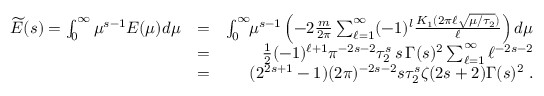<formula> <loc_0><loc_0><loc_500><loc_500>\begin{array} { r l r } { \widetilde { E } ( s ) = \int _ { 0 } ^ { \infty } \mu ^ { s - 1 } E ( \mu ) d \mu } & { = } & { \int _ { 0 } ^ { \infty } \, \mu ^ { s - 1 } \left ( - 2 { \frac { m } { 2 \pi } } \sum _ { \ell = 1 } ^ { \infty } ( - 1 ) ^ { l } { \frac { K _ { 1 } ( 2 \pi \ell \sqrt { \mu / \tau _ { 2 } } ) } { \ell } } \right ) d \mu } \\ & { = } & { { \frac { 1 } { 2 } } ( - 1 ) ^ { \ell + 1 } \pi ^ { - 2 s - 2 } \tau _ { 2 } ^ { s } \, s \, \Gamma ( s ) ^ { 2 } \sum _ { \ell = 1 } ^ { \infty } \ell ^ { - 2 s - 2 } } \\ & { = } & { ( 2 ^ { 2 s + 1 } - 1 ) ( 2 \pi ) ^ { - 2 s - 2 } s \tau _ { 2 } ^ { s } \zeta ( 2 s + 2 ) \Gamma ( s ) ^ { 2 } \, . } \end{array}</formula> 